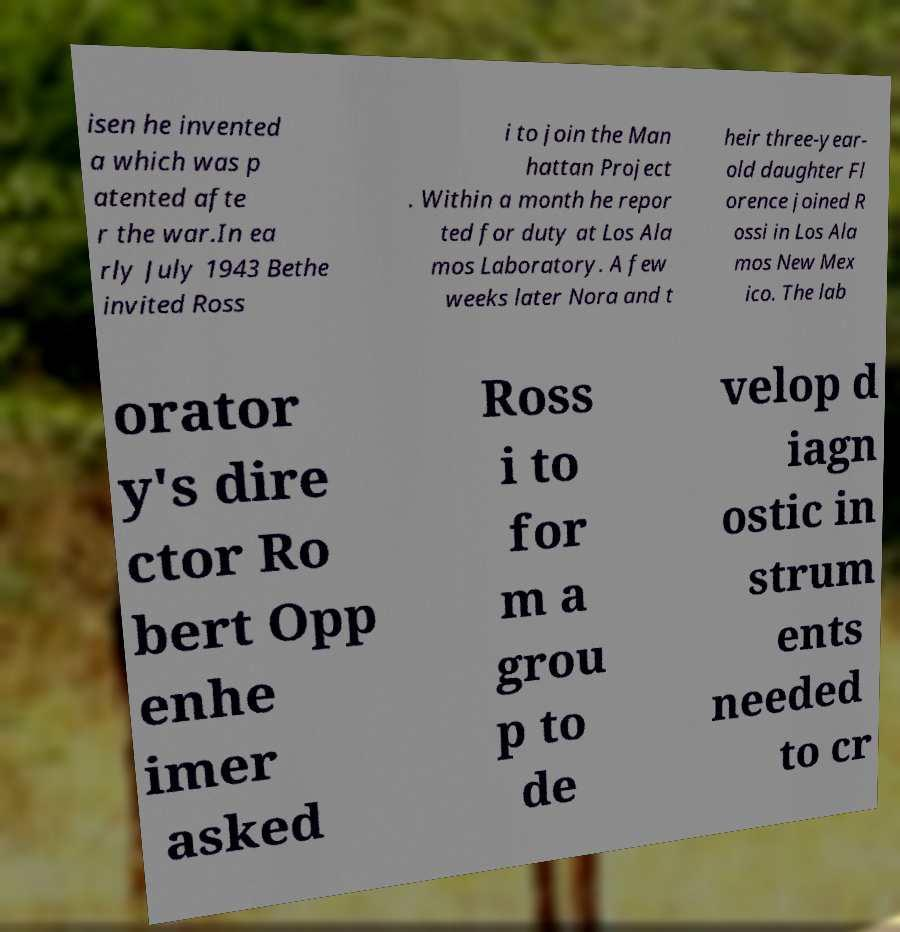Please read and relay the text visible in this image. What does it say? isen he invented a which was p atented afte r the war.In ea rly July 1943 Bethe invited Ross i to join the Man hattan Project . Within a month he repor ted for duty at Los Ala mos Laboratory. A few weeks later Nora and t heir three-year- old daughter Fl orence joined R ossi in Los Ala mos New Mex ico. The lab orator y's dire ctor Ro bert Opp enhe imer asked Ross i to for m a grou p to de velop d iagn ostic in strum ents needed to cr 